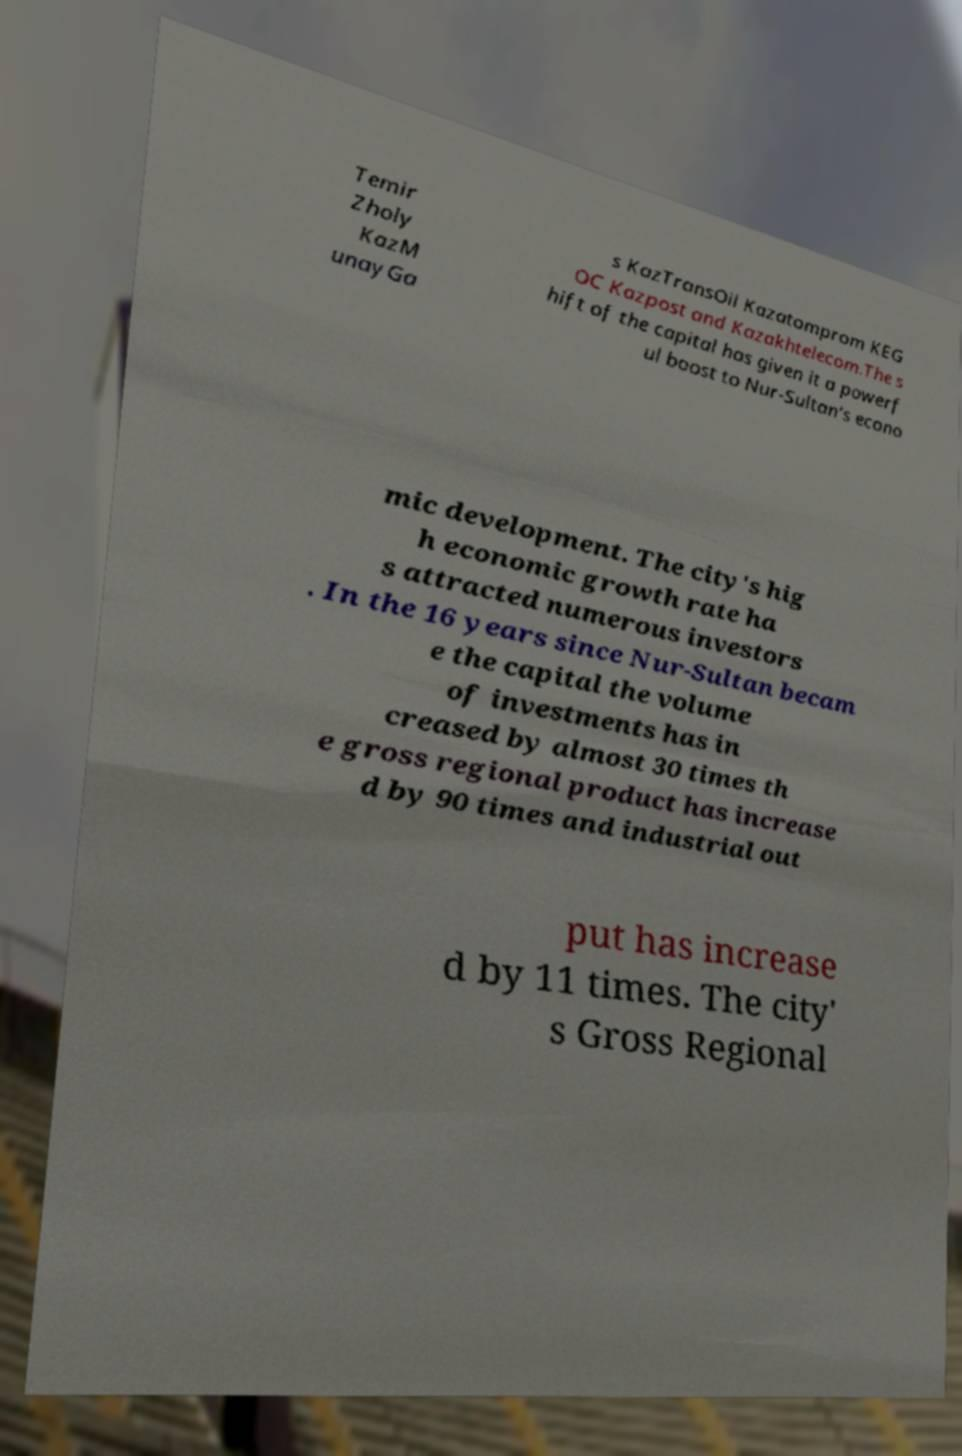I need the written content from this picture converted into text. Can you do that? Temir Zholy KazM unayGa s KazTransOil Kazatomprom KEG OC Kazpost and Kazakhtelecom.The s hift of the capital has given it a powerf ul boost to Nur-Sultan's econo mic development. The city's hig h economic growth rate ha s attracted numerous investors . In the 16 years since Nur-Sultan becam e the capital the volume of investments has in creased by almost 30 times th e gross regional product has increase d by 90 times and industrial out put has increase d by 11 times. The city' s Gross Regional 